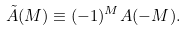Convert formula to latex. <formula><loc_0><loc_0><loc_500><loc_500>\tilde { A } ( M ) \equiv ( - 1 ) ^ { M } A ( - M ) .</formula> 